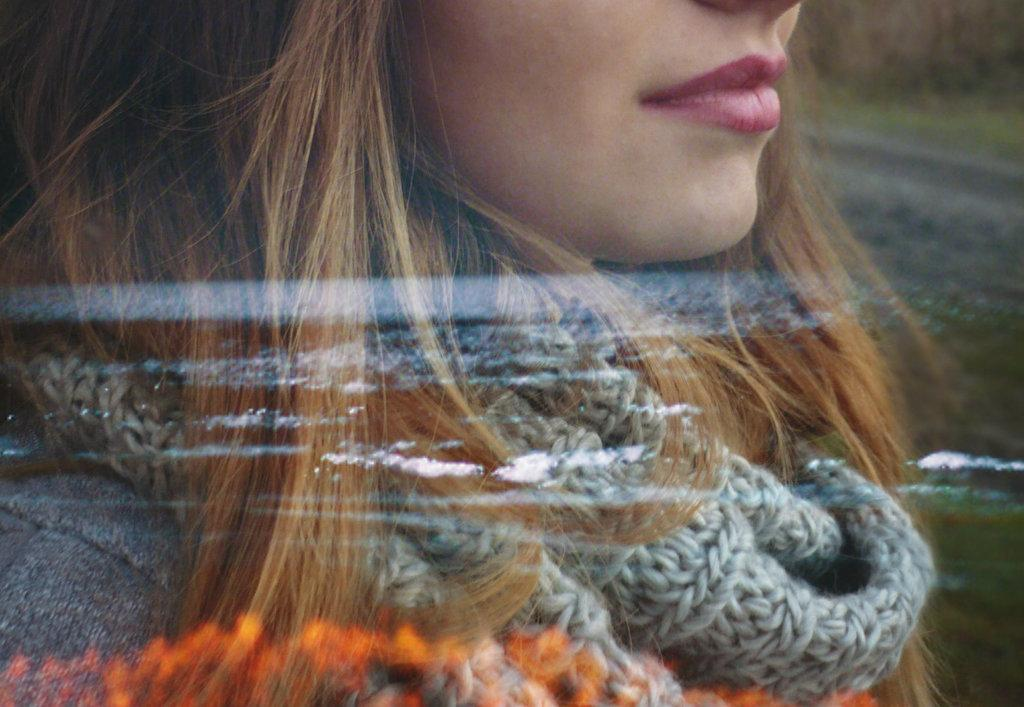What type of material is visible in the image? There is a transparent material in the image. Can you describe the person behind the transparent material? There is a woman with a scarf behind the transparent material. What type of cracker is being used to mark the territory in the image? There is no cracker or territory present in the image. 